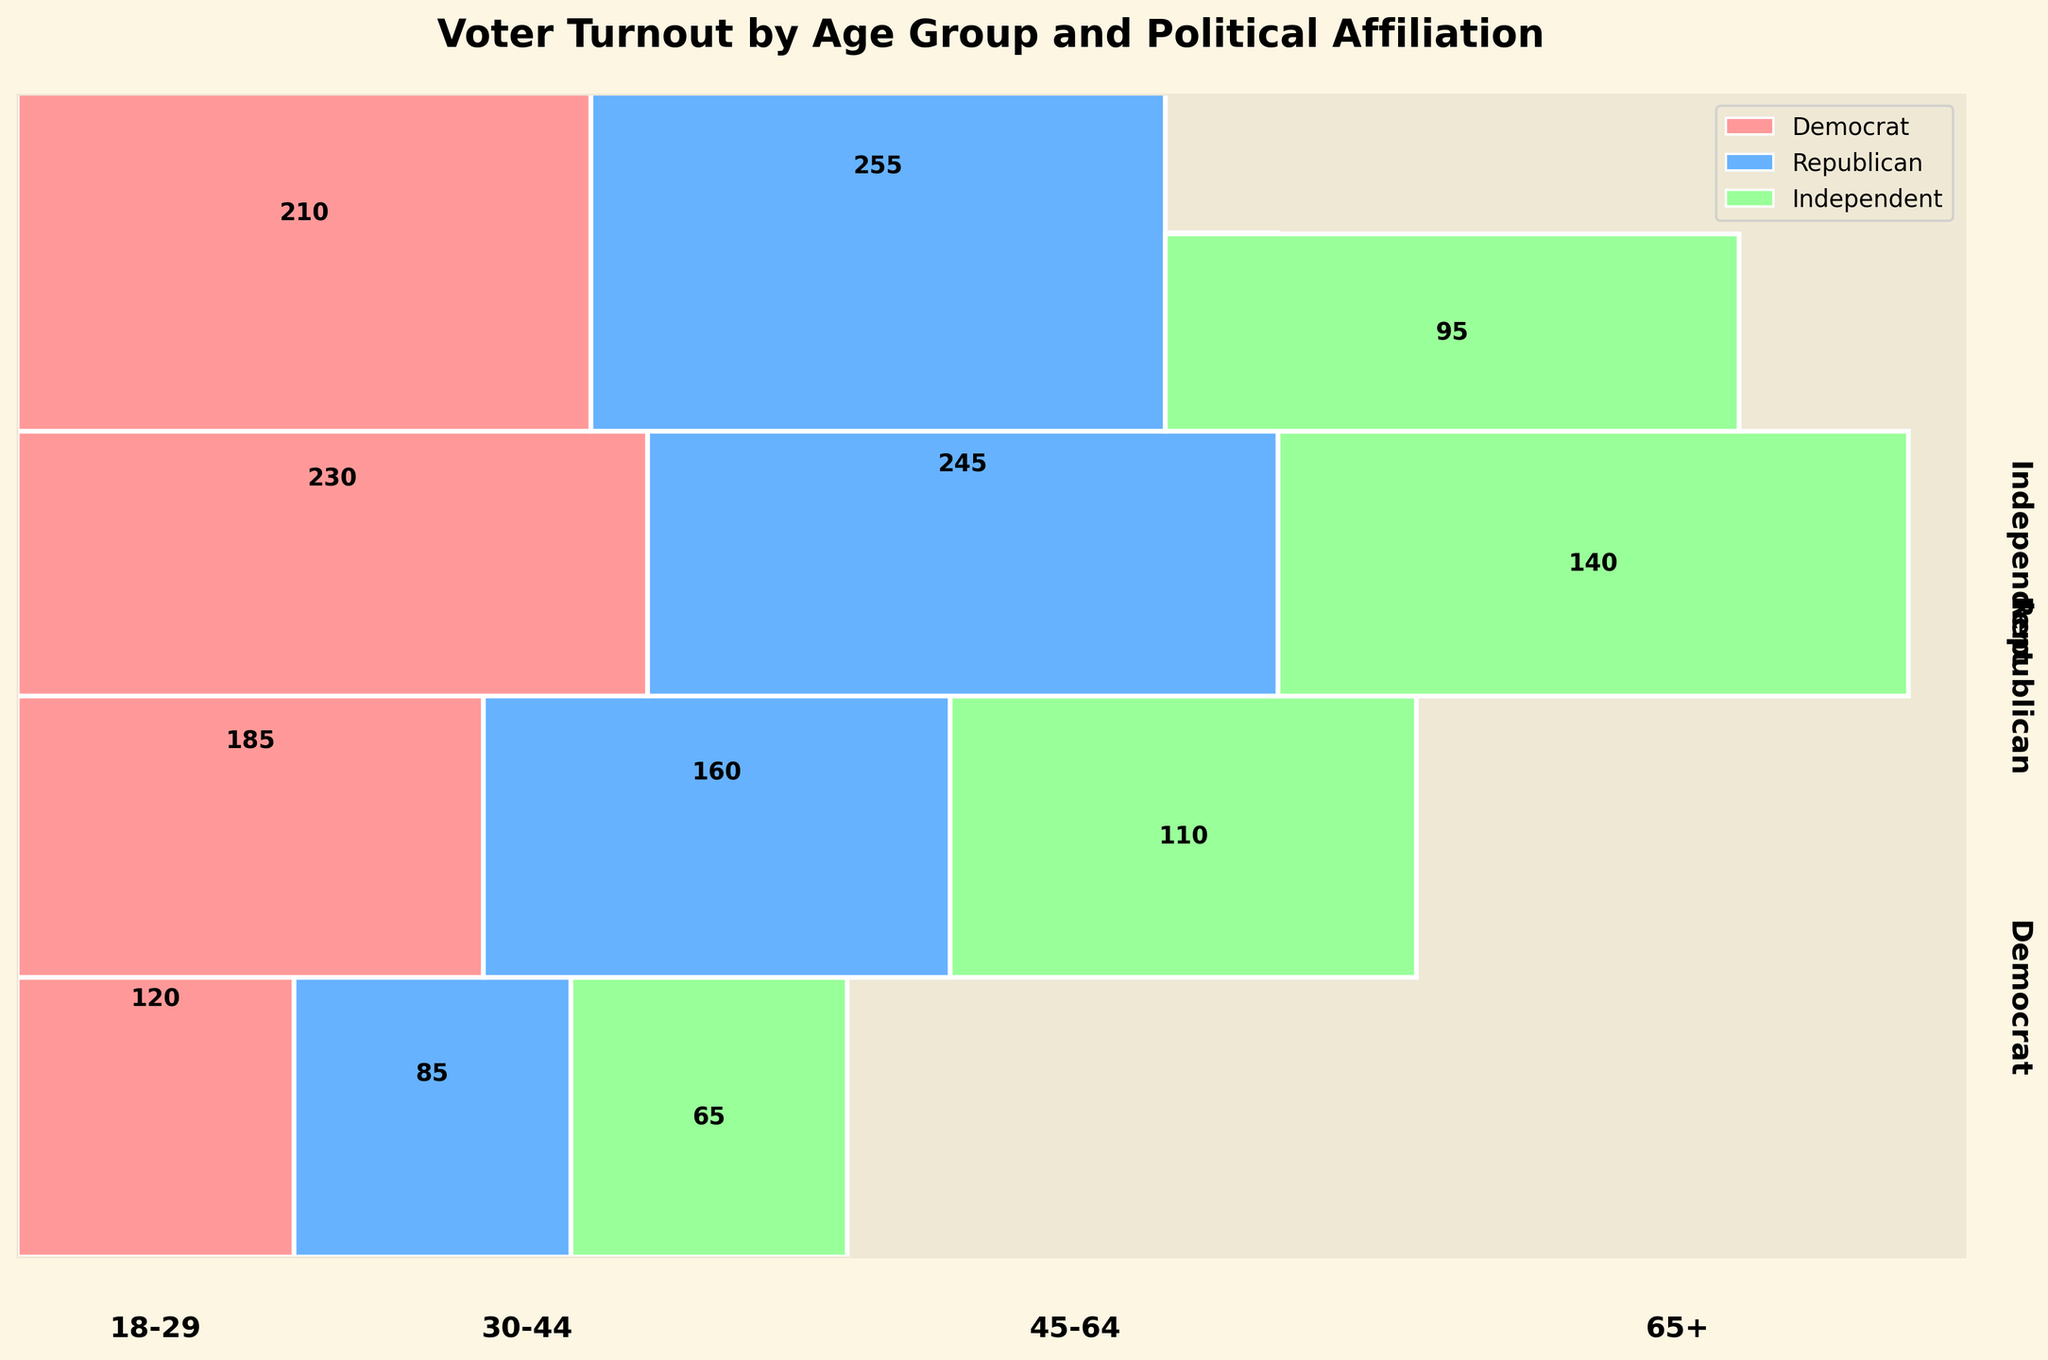What is the total voter turnout for the 18-29 age group? The voter turnout for the 18-29 age group includes Democrats (120), Republicans (85), and Independents (65). Summing these values gives 120 + 85 + 65 = 270.
Answer: 270 Which age group has the highest overall voter turnout? By examining the voter turnout for each age group: 18-29 (270), 30-44 (455), 45-64 (615), 65+ (560), the 45-64 age group has the highest at 615.
Answer: 45-64 Among the 30-44 age group, which political affiliation has the highest voter turnout? The voter turnout for the 30-44 age group is Democrats (185), Republicans (160), and Independents (110). Democrats have the highest at 185.
Answer: Democrats Compare the voter turnout for Independents in the 18-29 age group to those in the 65+ age group. Which is higher and by how much? Independents in the 18-29 age group have 65 voters, while those in the 65+ age group have 95 voters. 95 - 65 = 30, so the 65+ group is higher by 30.
Answer: 65+, by 30 What is the proportion of Democratic voters in the 65+ age group relative to their total voter turnout? In the 65+ age group, there are 560 voters in total and 210 are Democrats. The proportion is 210 / 560 = 0.375 or 37.5%.
Answer: 37.5% Across all age groups, which political affiliation has the most variable voter turnout? Reviewing the voter turnout numbers: Democrats (120, 185, 230, 210), Republicans (85, 160, 245, 255), Independents (65, 110, 140, 95). Republicans show a wider range from 85 to 255.
Answer: Republicans Which age group has the lowest number of Independent voters? The number of Independent voters in each age group is: 18-29 (65), 30-44 (110), 45-64 (140), 65+ (95). The 18-29 group has the lowest at 65.
Answer: 18-29 Between Democrats and Republicans in the 45-64 age group, who has a higher voter turnout and by how much? In the 45-64 age group, Democrats have 230 voters while Republicans have 245. 245 - 230 = 15, so Republicans have 15 more voters.
Answer: Republicans, by 15 What percentage of the total voter turnout for the 30-44 age group does the Republican affiliation represent? Total turnout for 30-44 is 455, with Republicans making up 160. The percentage is (160 / 455) * 100 ≈ 35.2%.
Answer: 35.2% How does the voter turnout for Independents in the 30-44 age group compare to Democrats in the same group? In the 30-44 age group, Independents have 110 voters while Democrats have 185. Democrats have 75 more voters than Independents (185 - 110 = 75).
Answer: Democrats, by 75 